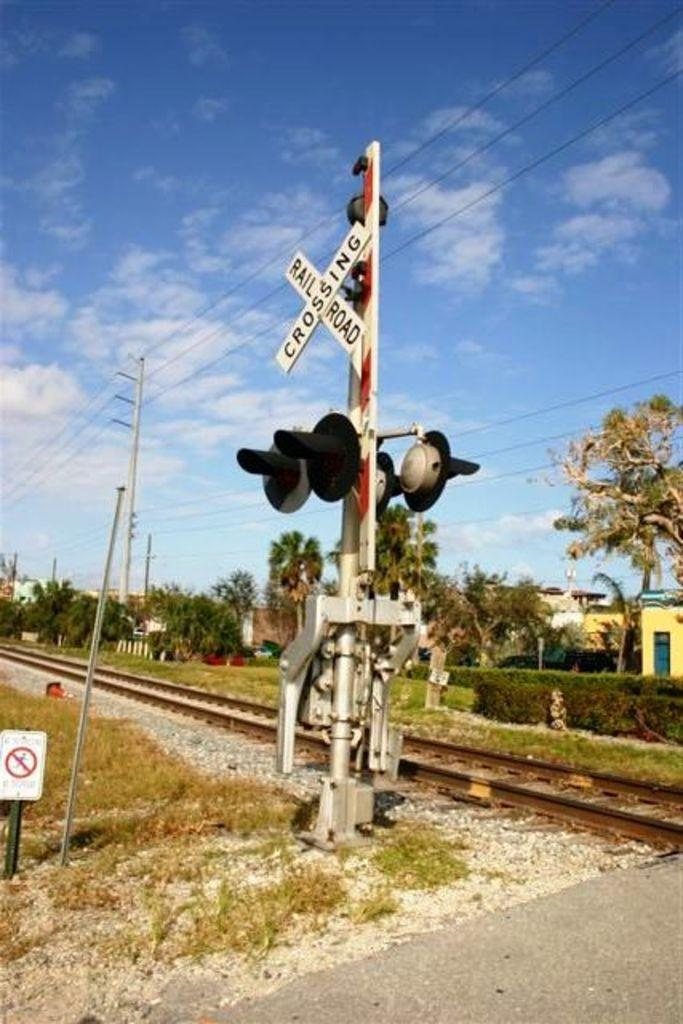<image>
Offer a succinct explanation of the picture presented. A railroad track has a sign on white slates that reads Railroad Crossing." 